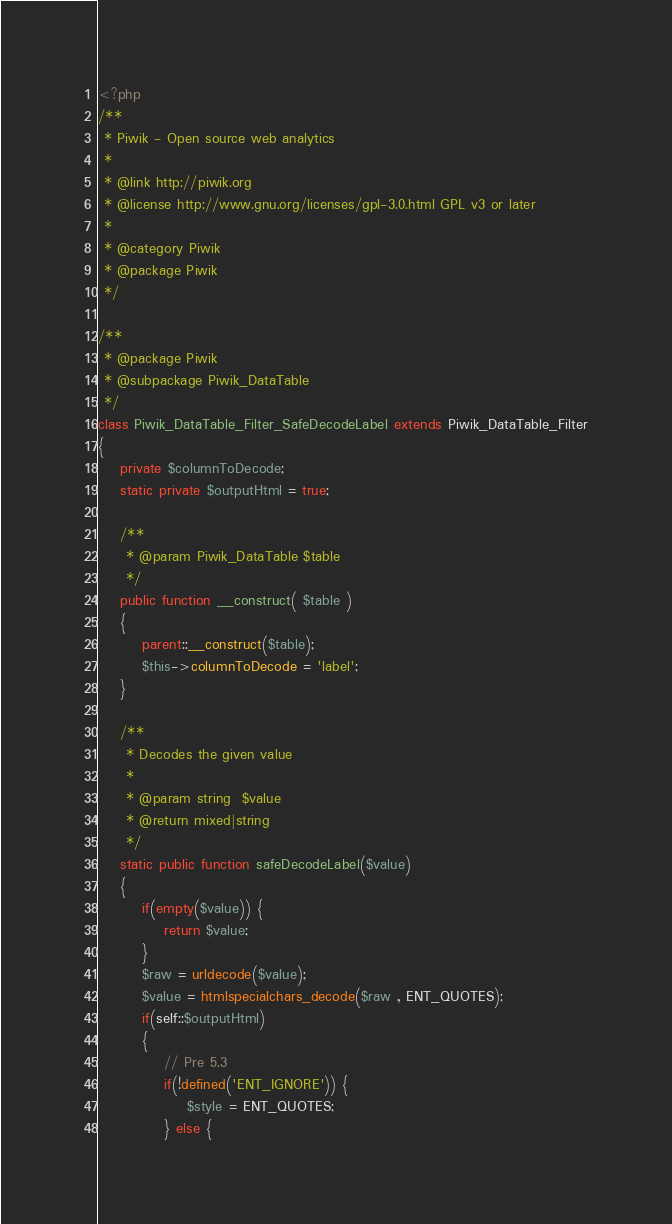Convert code to text. <code><loc_0><loc_0><loc_500><loc_500><_PHP_><?php
/**
 * Piwik - Open source web analytics
 * 
 * @link http://piwik.org
 * @license http://www.gnu.org/licenses/gpl-3.0.html GPL v3 or later
 * 
 * @category Piwik
 * @package Piwik
 */

/**
 * @package Piwik
 * @subpackage Piwik_DataTable
 */
class Piwik_DataTable_Filter_SafeDecodeLabel extends Piwik_DataTable_Filter
{
	private $columnToDecode;
	static private $outputHtml = true;

	/**
	 * @param Piwik_DataTable $table
	 */
	public function __construct( $table )
	{
		parent::__construct($table);
		$this->columnToDecode = 'label';
	}

	/**
	 * Decodes the given value
	 *
	 * @param string  $value
	 * @return mixed|string
	 */
	static public function safeDecodeLabel($value)
	{
		if(empty($value)) {
			return $value;
		}
		$raw = urldecode($value);
		$value = htmlspecialchars_decode($raw , ENT_QUOTES);
		if(self::$outputHtml)
		{
			// Pre 5.3
			if(!defined('ENT_IGNORE')) {
				$style = ENT_QUOTES;
			} else {</code> 